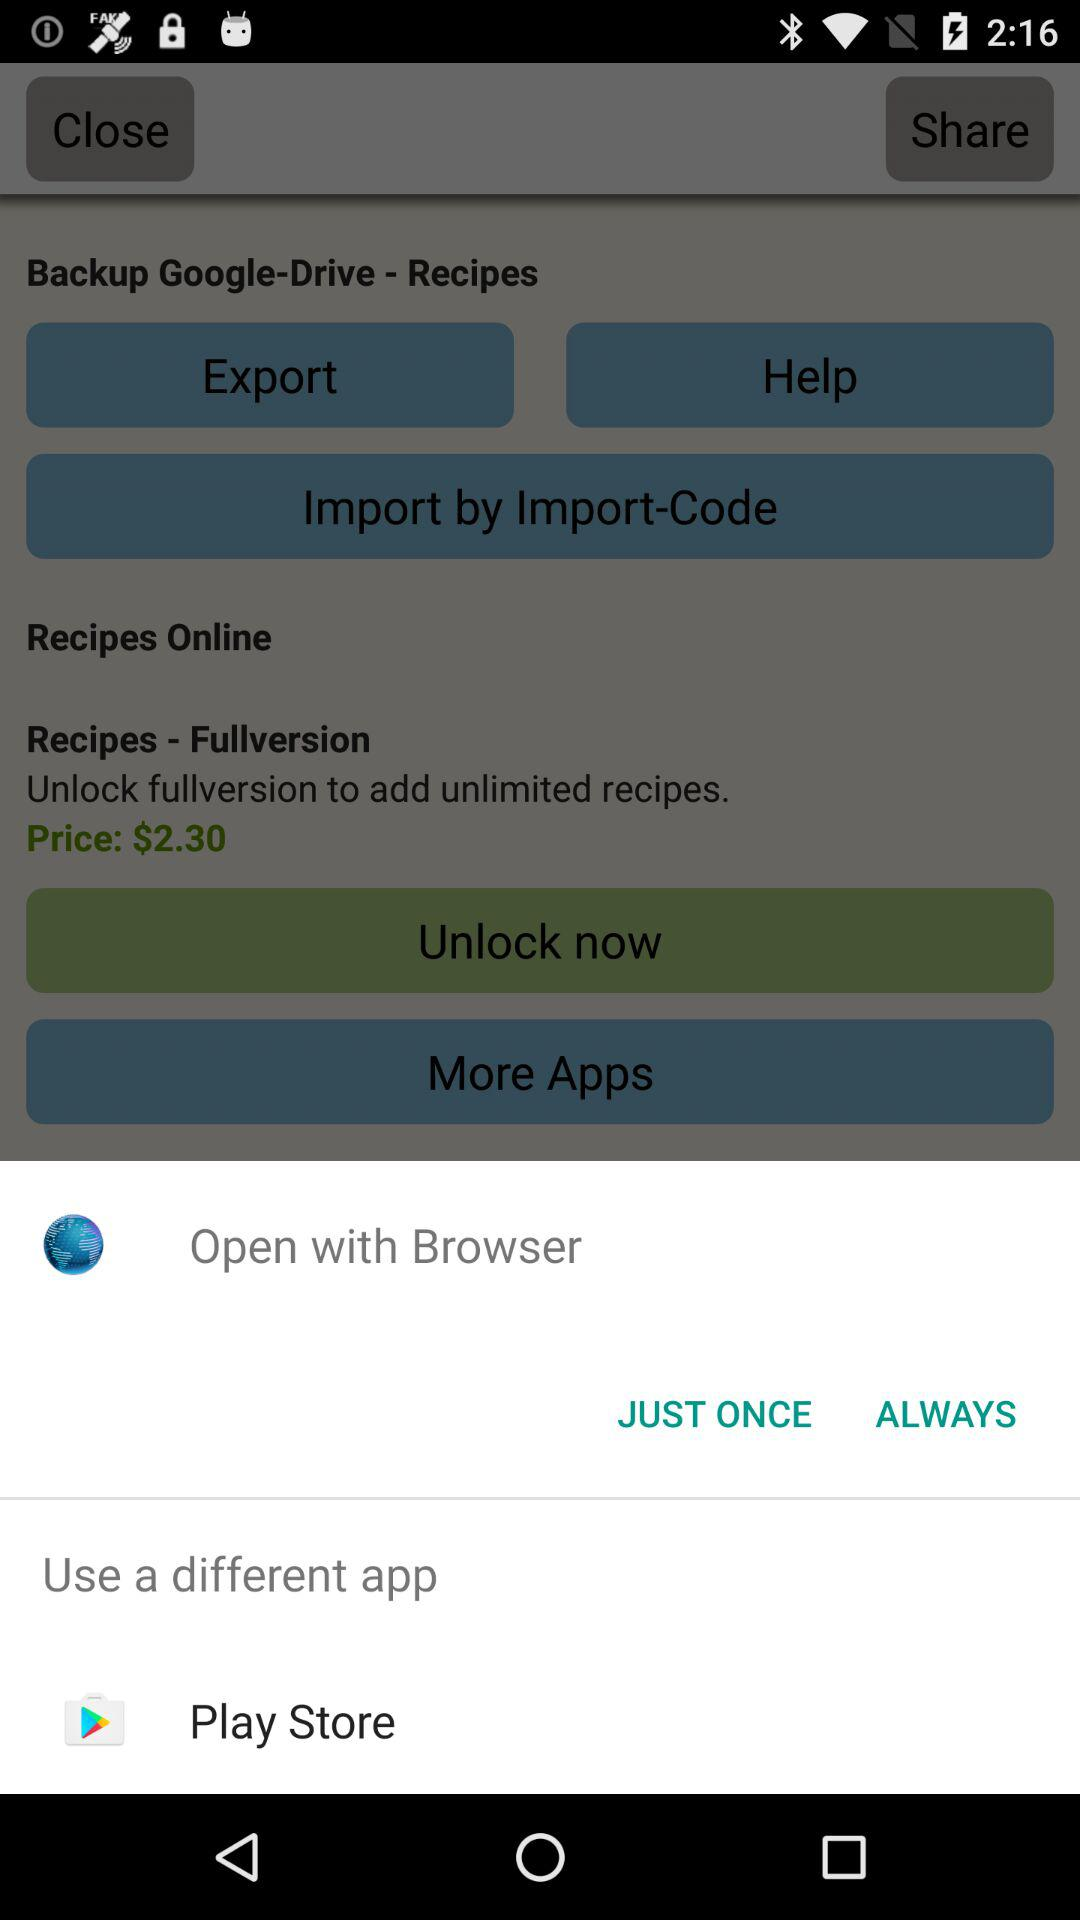What is the price to unlock recipes? The price is $2.30. 